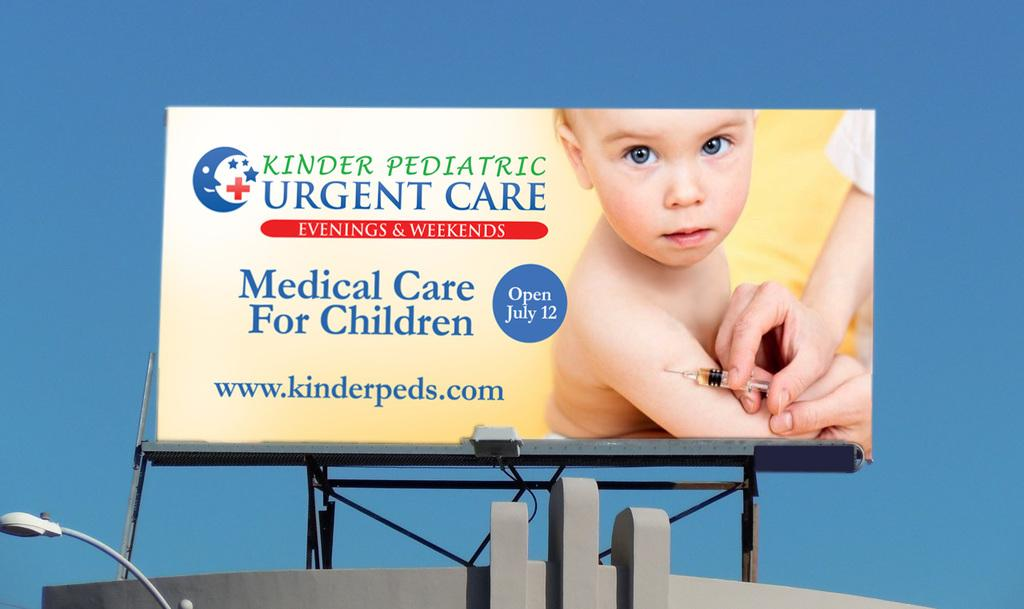Provide a one-sentence caption for the provided image. A huge poster of a nurse putting a injection on a baby that says Urgent Care. 